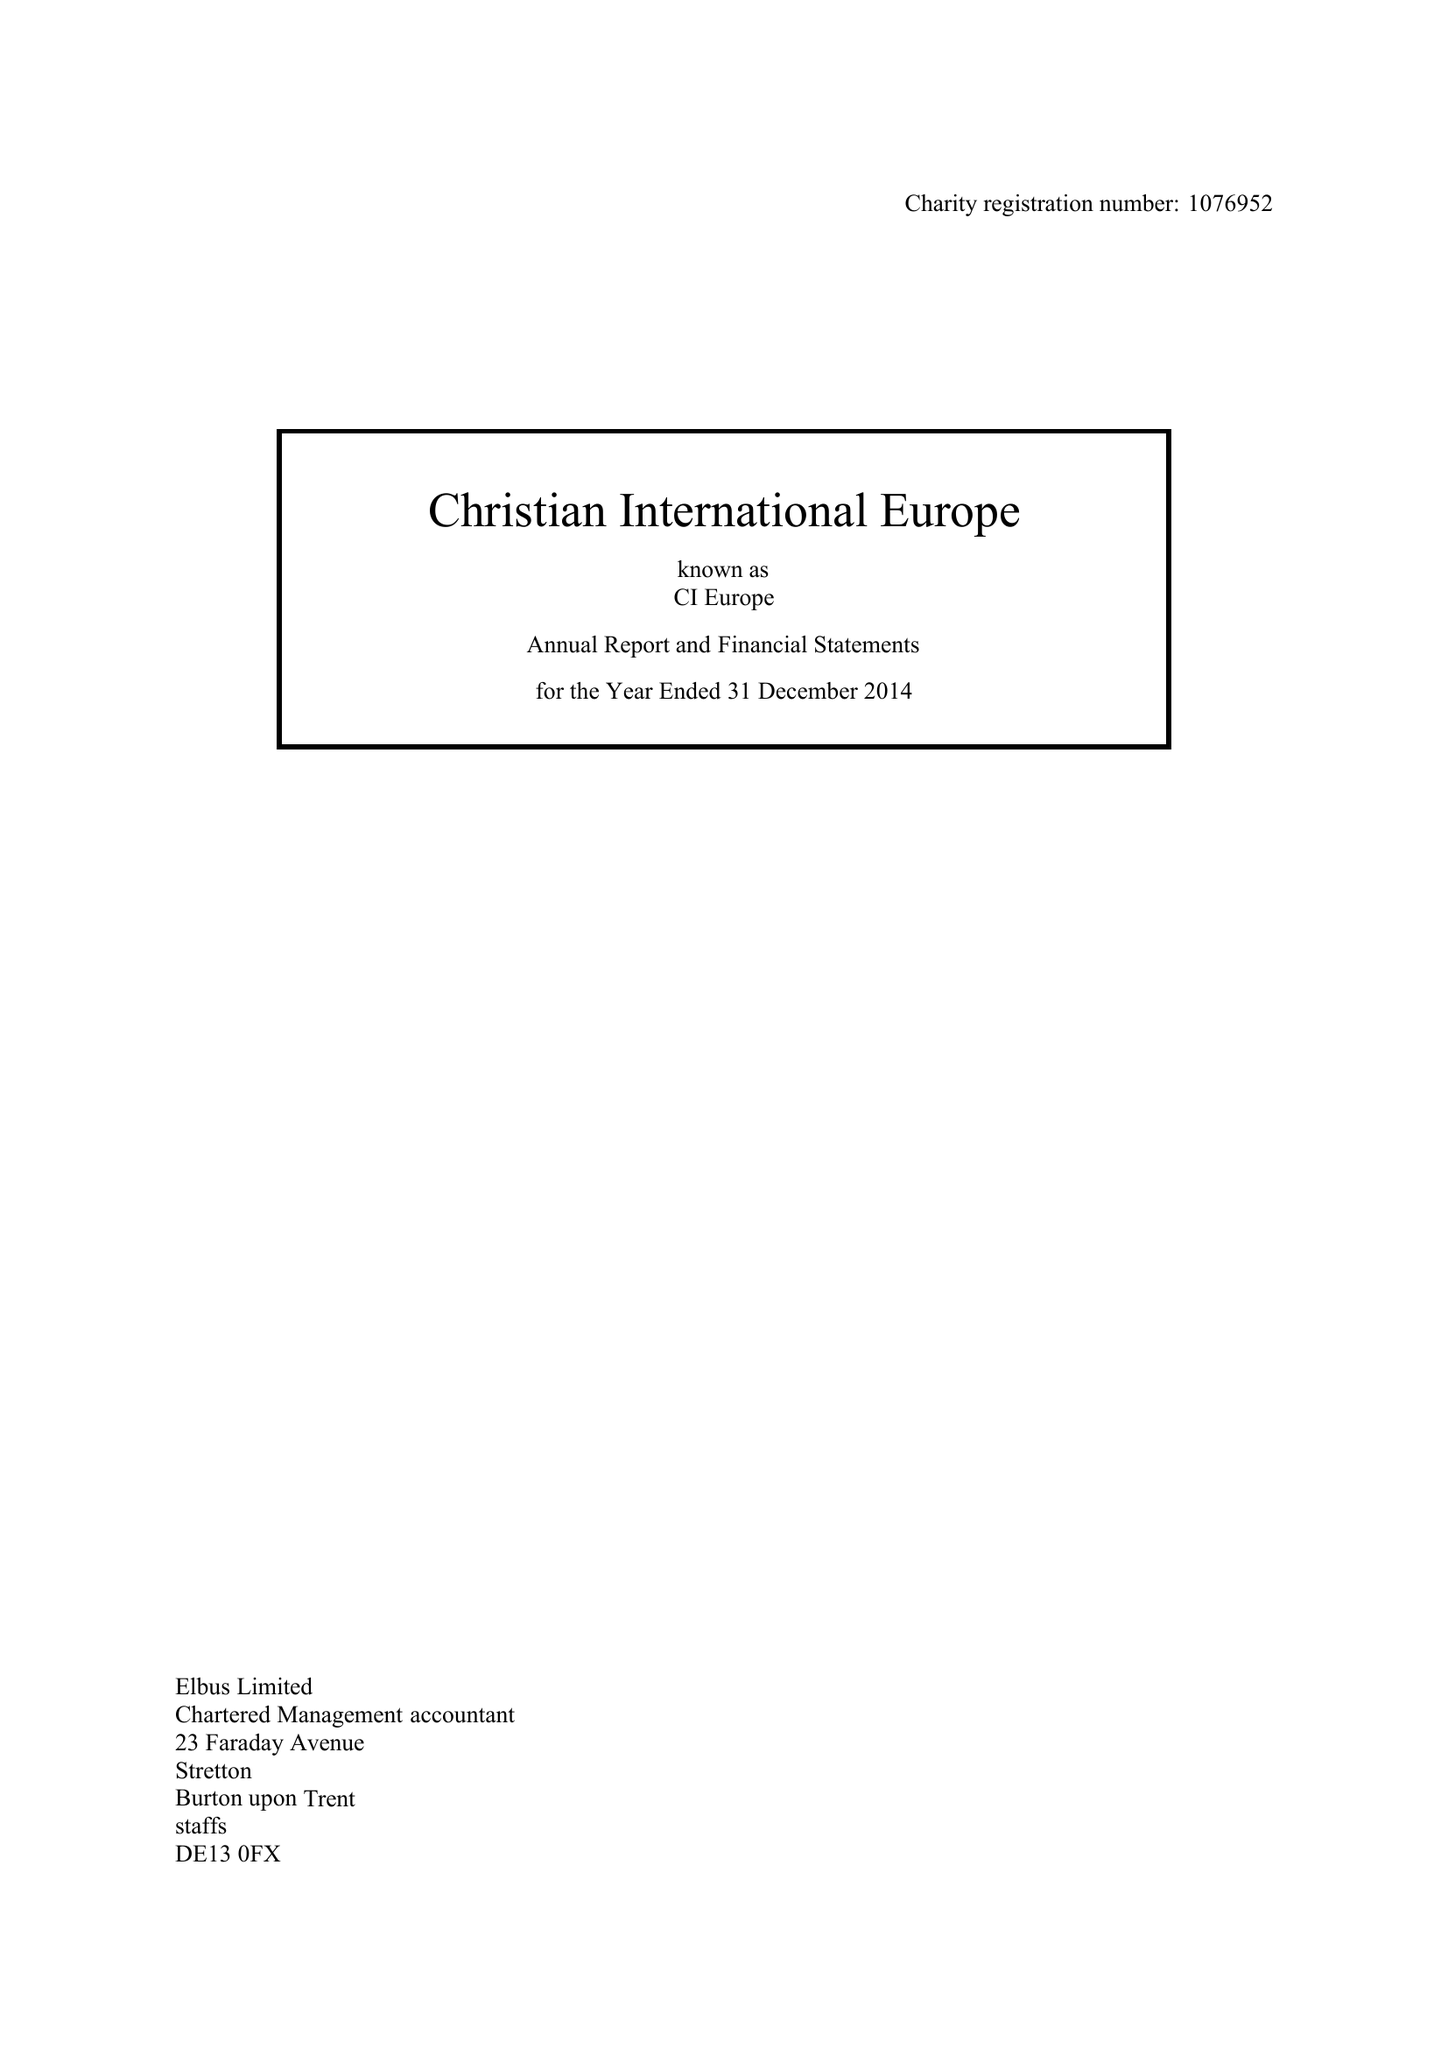What is the value for the income_annually_in_british_pounds?
Answer the question using a single word or phrase. 140039.00 